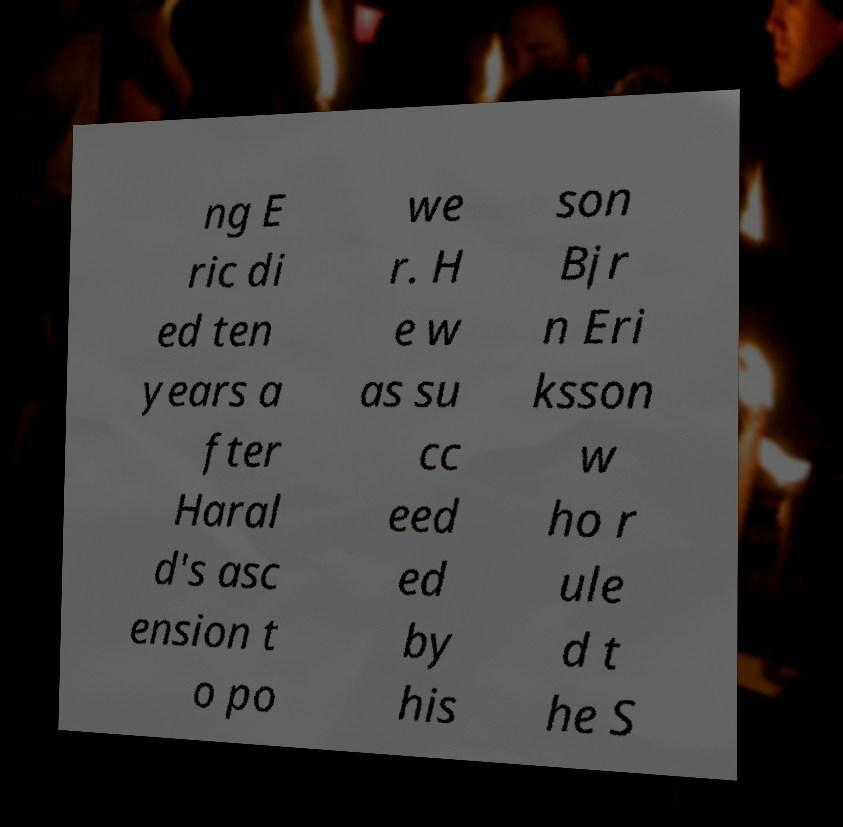Can you accurately transcribe the text from the provided image for me? ng E ric di ed ten years a fter Haral d's asc ension t o po we r. H e w as su cc eed ed by his son Bjr n Eri ksson w ho r ule d t he S 